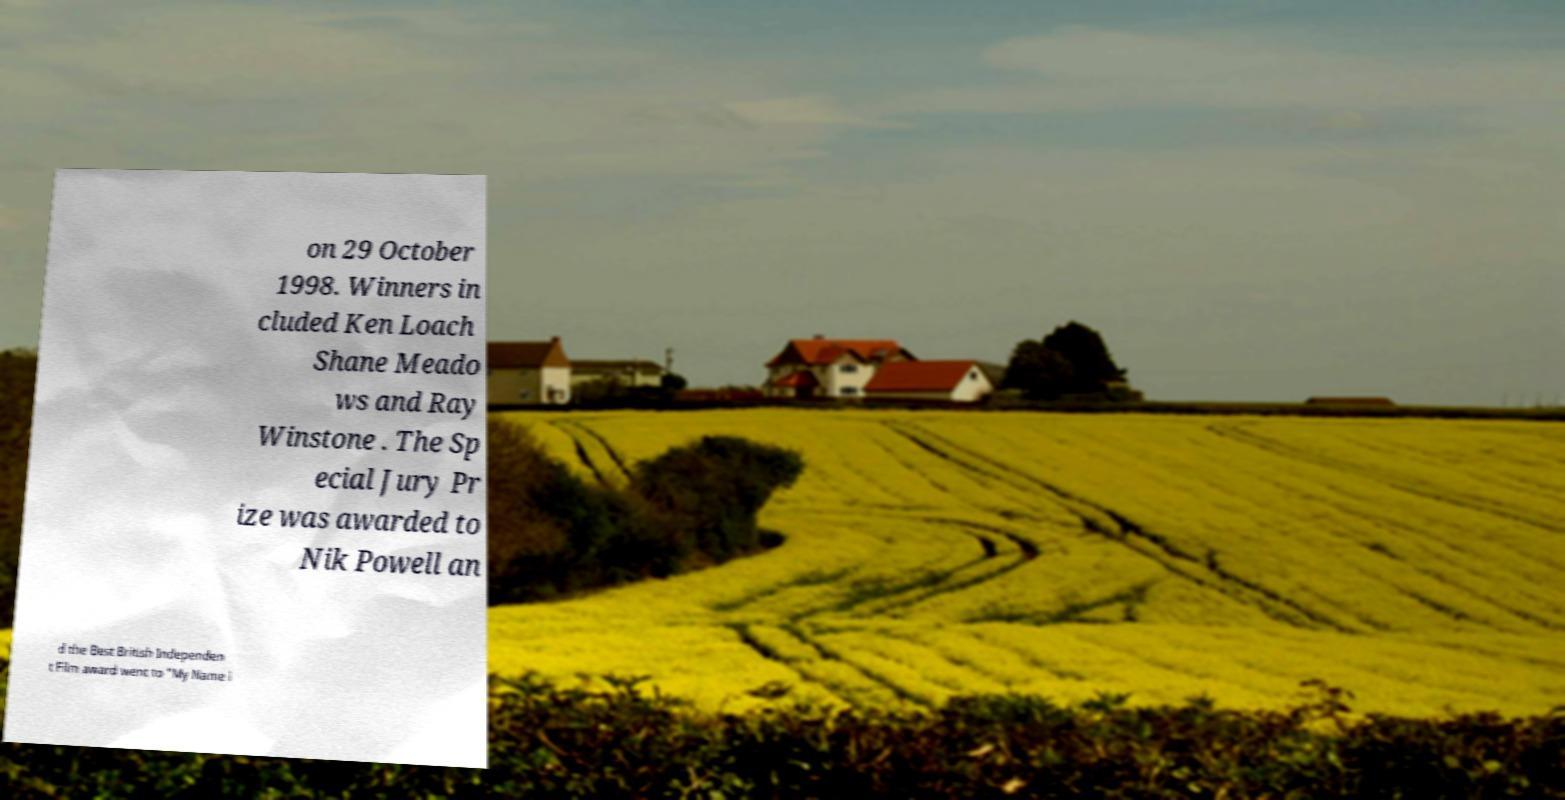Please identify and transcribe the text found in this image. on 29 October 1998. Winners in cluded Ken Loach Shane Meado ws and Ray Winstone . The Sp ecial Jury Pr ize was awarded to Nik Powell an d the Best British Independen t Film award went to "My Name i 